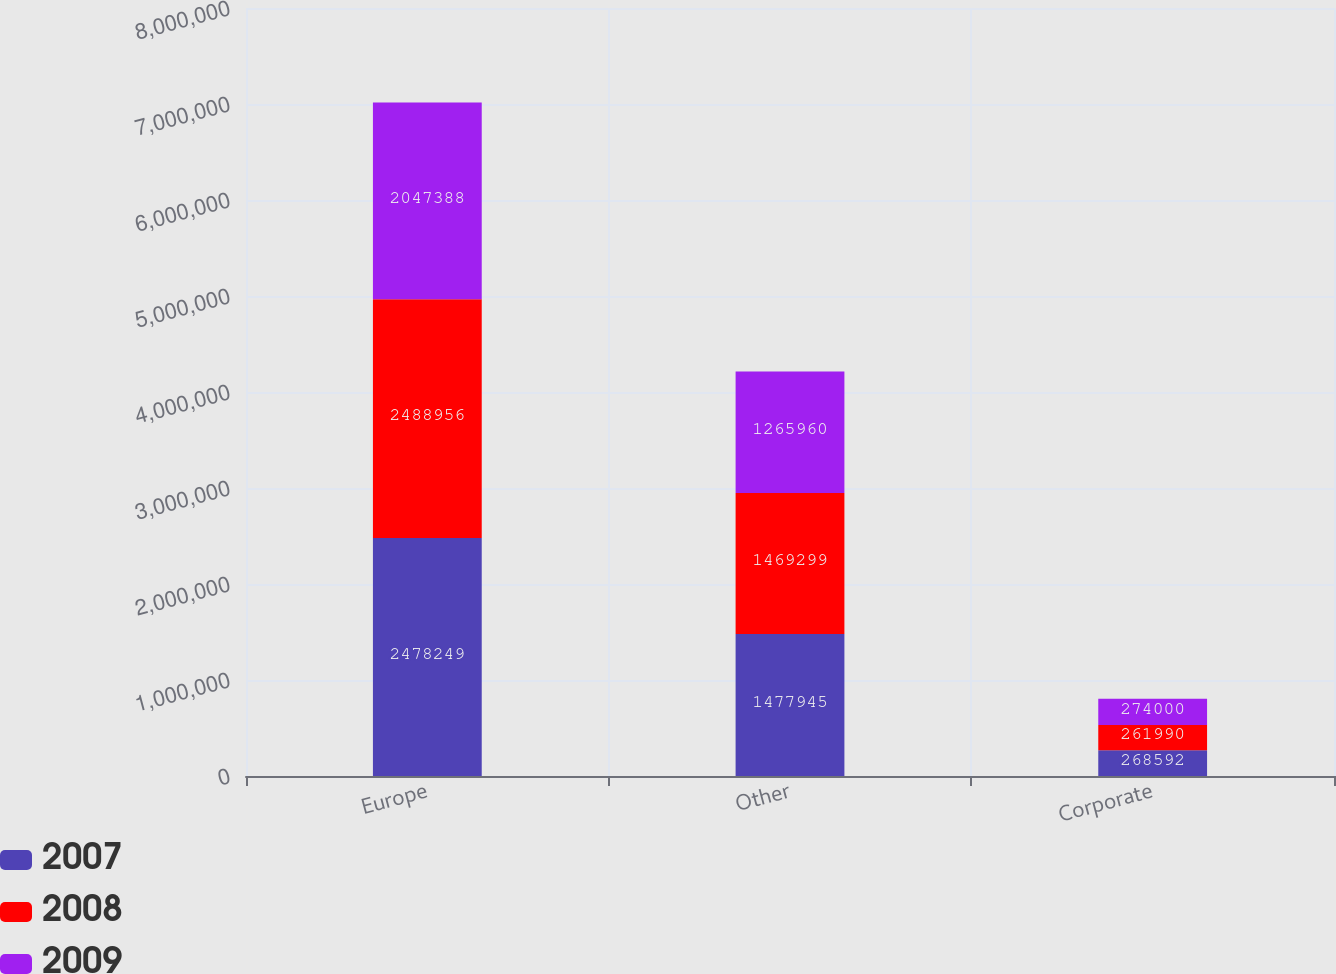<chart> <loc_0><loc_0><loc_500><loc_500><stacked_bar_chart><ecel><fcel>Europe<fcel>Other<fcel>Corporate<nl><fcel>2007<fcel>2.47825e+06<fcel>1.47794e+06<fcel>268592<nl><fcel>2008<fcel>2.48896e+06<fcel>1.4693e+06<fcel>261990<nl><fcel>2009<fcel>2.04739e+06<fcel>1.26596e+06<fcel>274000<nl></chart> 